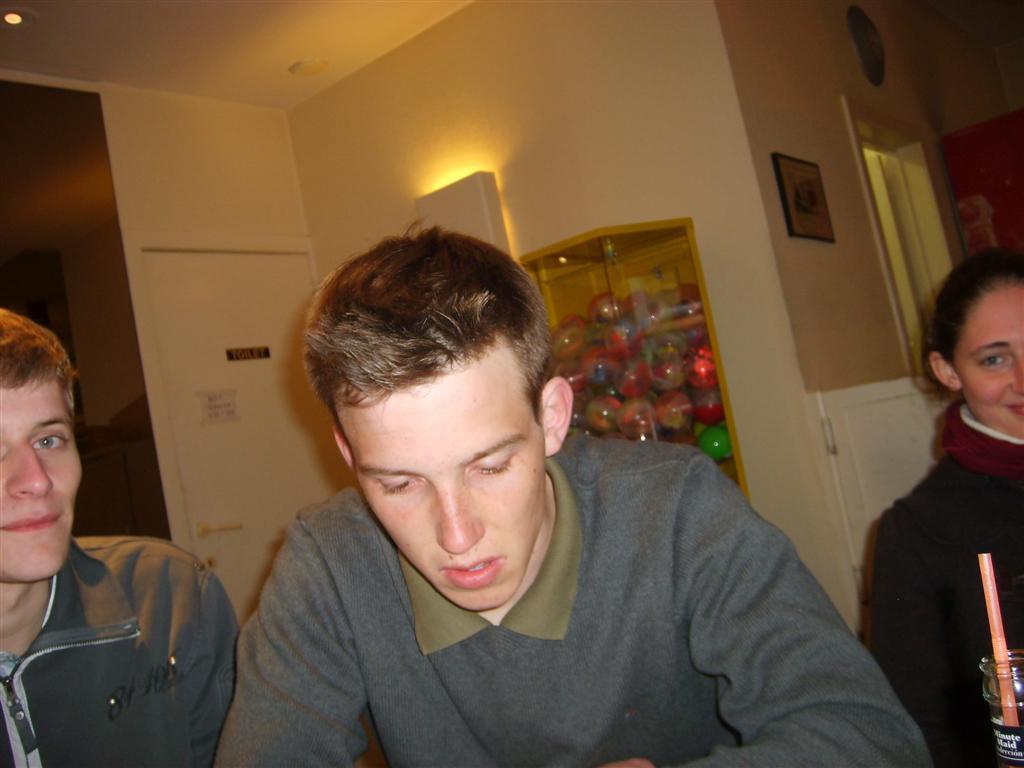Can you describe this image briefly? In this picture, we see three people. Among them, two are boys and one is a girl. Behind them, we see a wall in white color and we even see a rack in which many balls are placed. Beside that, we see a white color door and beside the door, we see a wall in brown color. On the right top of the picture, we see a photo frame which is placed on the white wall. 